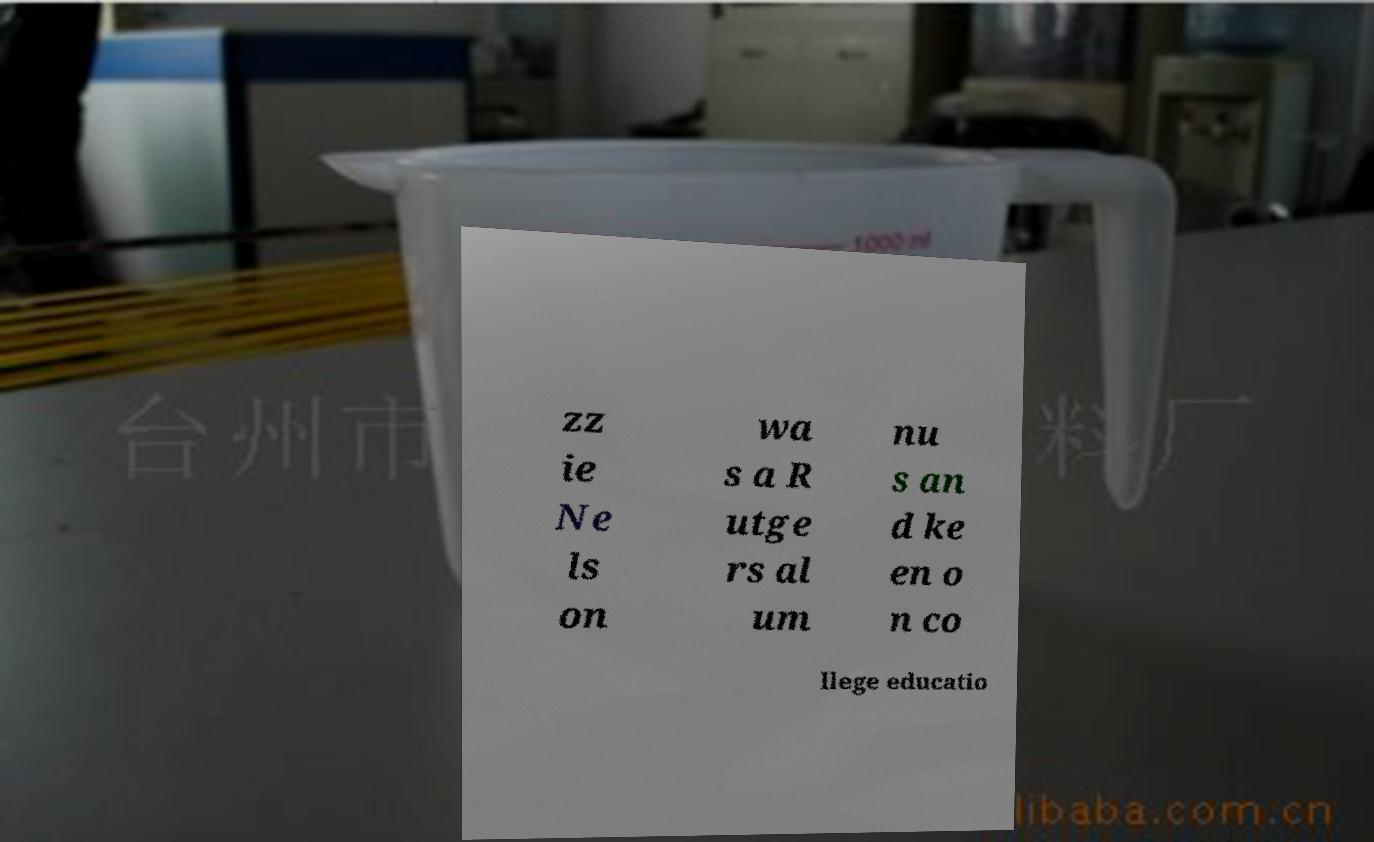Please identify and transcribe the text found in this image. zz ie Ne ls on wa s a R utge rs al um nu s an d ke en o n co llege educatio 